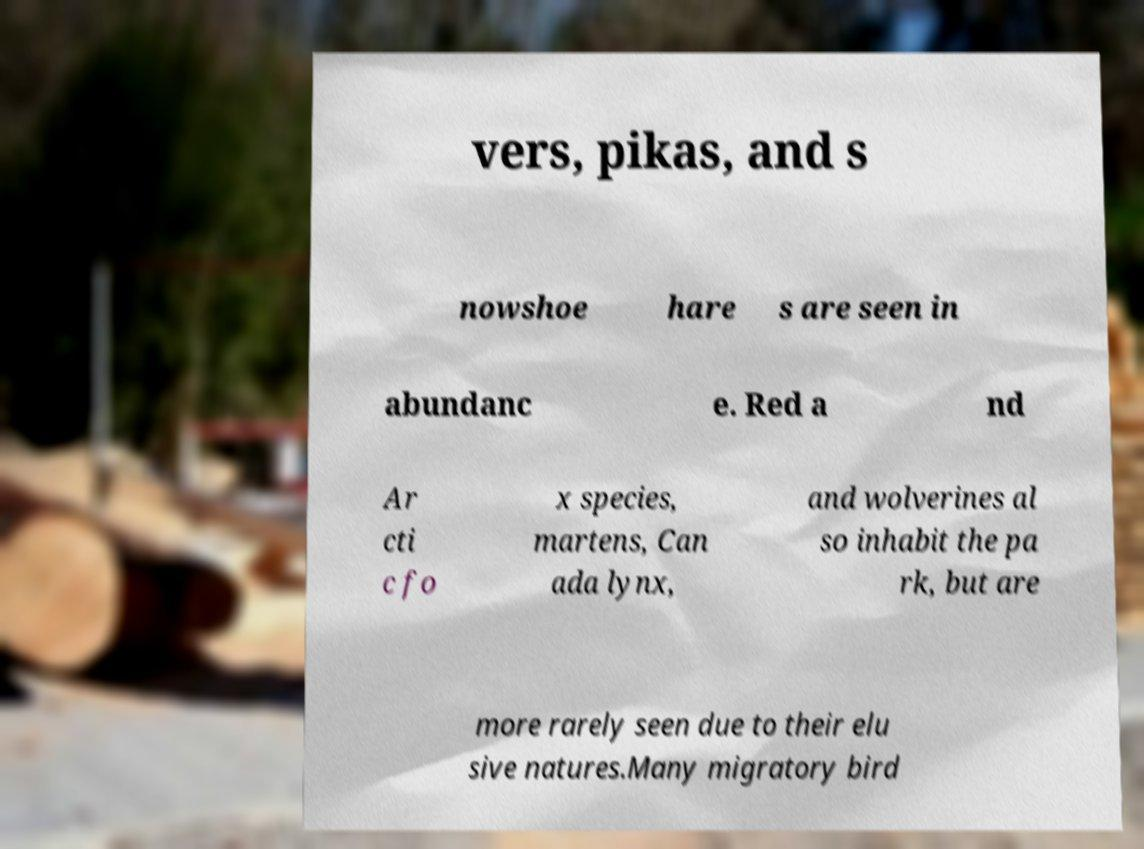Can you read and provide the text displayed in the image?This photo seems to have some interesting text. Can you extract and type it out for me? vers, pikas, and s nowshoe hare s are seen in abundanc e. Red a nd Ar cti c fo x species, martens, Can ada lynx, and wolverines al so inhabit the pa rk, but are more rarely seen due to their elu sive natures.Many migratory bird 